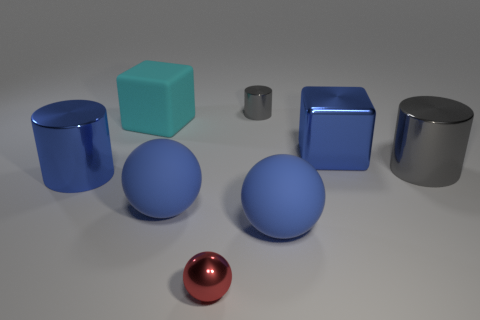Add 1 red metallic objects. How many objects exist? 9 Subtract all cylinders. How many objects are left? 5 Subtract all big gray shiny objects. Subtract all matte blocks. How many objects are left? 6 Add 7 blue metal cylinders. How many blue metal cylinders are left? 8 Add 6 blue metal objects. How many blue metal objects exist? 8 Subtract 0 yellow balls. How many objects are left? 8 